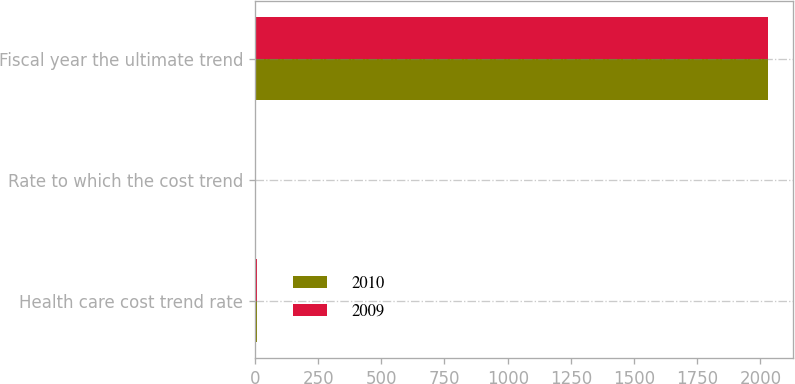<chart> <loc_0><loc_0><loc_500><loc_500><stacked_bar_chart><ecel><fcel>Health care cost trend rate<fcel>Rate to which the cost trend<fcel>Fiscal year the ultimate trend<nl><fcel>2010<fcel>7.98<fcel>4.5<fcel>2029<nl><fcel>2009<fcel>8.23<fcel>4.5<fcel>2029<nl></chart> 